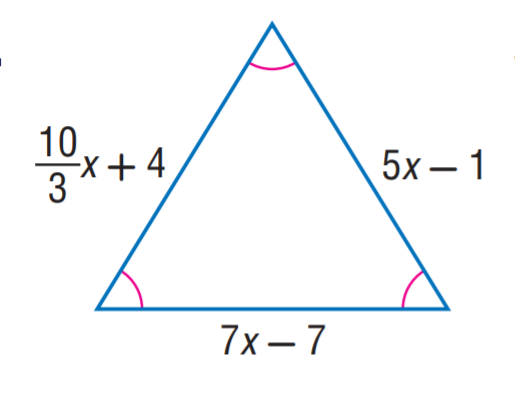Answer the mathemtical geometry problem and directly provide the correct option letter.
Question: Find x.
Choices: A: 1 B: 3 C: 5 D: 7 B 